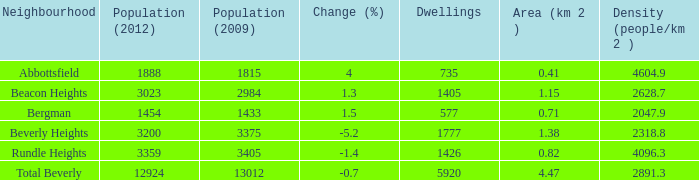What is the number of dwellings in beverly heights with a change percentage higher than -5.2? None. 